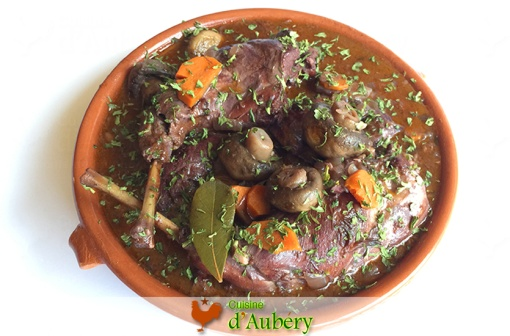What ingredients can you identify in this dish? In this delicious-looking dish, identifiable ingredients include succulent chicken pieces, earthy mushrooms, and bright orange slices of carrots. The dish is topped with finely chopped green herbs and a visible bay leaf, all immersed in a rich, dark sauce. 